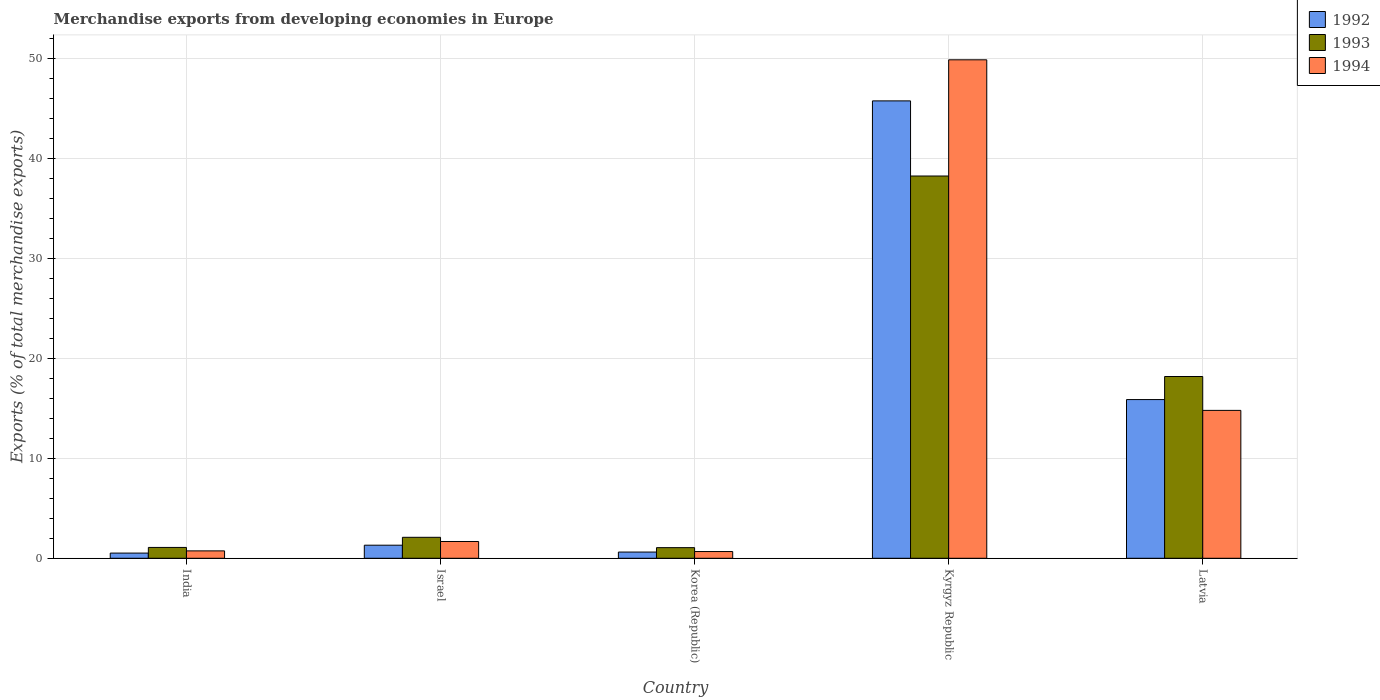How many bars are there on the 2nd tick from the right?
Give a very brief answer. 3. What is the label of the 4th group of bars from the left?
Give a very brief answer. Kyrgyz Republic. In how many cases, is the number of bars for a given country not equal to the number of legend labels?
Provide a succinct answer. 0. What is the percentage of total merchandise exports in 1993 in India?
Your answer should be very brief. 1.08. Across all countries, what is the maximum percentage of total merchandise exports in 1994?
Your answer should be compact. 49.84. Across all countries, what is the minimum percentage of total merchandise exports in 1993?
Your answer should be very brief. 1.06. In which country was the percentage of total merchandise exports in 1992 maximum?
Make the answer very short. Kyrgyz Republic. What is the total percentage of total merchandise exports in 1993 in the graph?
Your answer should be compact. 60.63. What is the difference between the percentage of total merchandise exports in 1993 in Israel and that in Korea (Republic)?
Your response must be concise. 1.03. What is the difference between the percentage of total merchandise exports in 1993 in Kyrgyz Republic and the percentage of total merchandise exports in 1994 in Latvia?
Your answer should be compact. 23.43. What is the average percentage of total merchandise exports in 1993 per country?
Provide a short and direct response. 12.13. What is the difference between the percentage of total merchandise exports of/in 1992 and percentage of total merchandise exports of/in 1993 in Korea (Republic)?
Ensure brevity in your answer.  -0.44. What is the ratio of the percentage of total merchandise exports in 1992 in Israel to that in Latvia?
Offer a very short reply. 0.08. Is the difference between the percentage of total merchandise exports in 1992 in Israel and Kyrgyz Republic greater than the difference between the percentage of total merchandise exports in 1993 in Israel and Kyrgyz Republic?
Keep it short and to the point. No. What is the difference between the highest and the second highest percentage of total merchandise exports in 1993?
Offer a terse response. 16.08. What is the difference between the highest and the lowest percentage of total merchandise exports in 1994?
Your answer should be compact. 49.16. In how many countries, is the percentage of total merchandise exports in 1993 greater than the average percentage of total merchandise exports in 1993 taken over all countries?
Your response must be concise. 2. Is the sum of the percentage of total merchandise exports in 1993 in India and Latvia greater than the maximum percentage of total merchandise exports in 1992 across all countries?
Your answer should be compact. No. What does the 3rd bar from the left in Kyrgyz Republic represents?
Provide a short and direct response. 1994. Is it the case that in every country, the sum of the percentage of total merchandise exports in 1992 and percentage of total merchandise exports in 1994 is greater than the percentage of total merchandise exports in 1993?
Make the answer very short. Yes. How many bars are there?
Offer a very short reply. 15. Are all the bars in the graph horizontal?
Your answer should be compact. No. How many countries are there in the graph?
Provide a succinct answer. 5. Does the graph contain any zero values?
Your answer should be compact. No. Where does the legend appear in the graph?
Provide a short and direct response. Top right. How many legend labels are there?
Provide a short and direct response. 3. How are the legend labels stacked?
Keep it short and to the point. Vertical. What is the title of the graph?
Offer a very short reply. Merchandise exports from developing economies in Europe. Does "1974" appear as one of the legend labels in the graph?
Make the answer very short. No. What is the label or title of the X-axis?
Keep it short and to the point. Country. What is the label or title of the Y-axis?
Give a very brief answer. Exports (% of total merchandise exports). What is the Exports (% of total merchandise exports) in 1992 in India?
Provide a succinct answer. 0.52. What is the Exports (% of total merchandise exports) in 1993 in India?
Provide a succinct answer. 1.08. What is the Exports (% of total merchandise exports) of 1994 in India?
Ensure brevity in your answer.  0.74. What is the Exports (% of total merchandise exports) in 1992 in Israel?
Keep it short and to the point. 1.31. What is the Exports (% of total merchandise exports) in 1993 in Israel?
Your answer should be very brief. 2.1. What is the Exports (% of total merchandise exports) of 1994 in Israel?
Your answer should be very brief. 1.68. What is the Exports (% of total merchandise exports) of 1992 in Korea (Republic)?
Offer a terse response. 0.62. What is the Exports (% of total merchandise exports) of 1993 in Korea (Republic)?
Your answer should be compact. 1.06. What is the Exports (% of total merchandise exports) of 1994 in Korea (Republic)?
Offer a very short reply. 0.67. What is the Exports (% of total merchandise exports) in 1992 in Kyrgyz Republic?
Offer a terse response. 45.73. What is the Exports (% of total merchandise exports) in 1993 in Kyrgyz Republic?
Ensure brevity in your answer.  38.22. What is the Exports (% of total merchandise exports) in 1994 in Kyrgyz Republic?
Make the answer very short. 49.84. What is the Exports (% of total merchandise exports) of 1992 in Latvia?
Ensure brevity in your answer.  15.87. What is the Exports (% of total merchandise exports) in 1993 in Latvia?
Provide a short and direct response. 18.17. What is the Exports (% of total merchandise exports) in 1994 in Latvia?
Your response must be concise. 14.79. Across all countries, what is the maximum Exports (% of total merchandise exports) of 1992?
Give a very brief answer. 45.73. Across all countries, what is the maximum Exports (% of total merchandise exports) in 1993?
Provide a succinct answer. 38.22. Across all countries, what is the maximum Exports (% of total merchandise exports) of 1994?
Your response must be concise. 49.84. Across all countries, what is the minimum Exports (% of total merchandise exports) of 1992?
Provide a succinct answer. 0.52. Across all countries, what is the minimum Exports (% of total merchandise exports) in 1993?
Offer a very short reply. 1.06. Across all countries, what is the minimum Exports (% of total merchandise exports) of 1994?
Your answer should be compact. 0.67. What is the total Exports (% of total merchandise exports) of 1992 in the graph?
Provide a short and direct response. 64.04. What is the total Exports (% of total merchandise exports) of 1993 in the graph?
Provide a short and direct response. 60.63. What is the total Exports (% of total merchandise exports) of 1994 in the graph?
Provide a short and direct response. 67.71. What is the difference between the Exports (% of total merchandise exports) of 1992 in India and that in Israel?
Offer a very short reply. -0.79. What is the difference between the Exports (% of total merchandise exports) in 1993 in India and that in Israel?
Your answer should be compact. -1.01. What is the difference between the Exports (% of total merchandise exports) in 1994 in India and that in Israel?
Provide a short and direct response. -0.94. What is the difference between the Exports (% of total merchandise exports) of 1992 in India and that in Korea (Republic)?
Provide a succinct answer. -0.1. What is the difference between the Exports (% of total merchandise exports) in 1993 in India and that in Korea (Republic)?
Provide a short and direct response. 0.02. What is the difference between the Exports (% of total merchandise exports) in 1994 in India and that in Korea (Republic)?
Your response must be concise. 0.07. What is the difference between the Exports (% of total merchandise exports) of 1992 in India and that in Kyrgyz Republic?
Your response must be concise. -45.21. What is the difference between the Exports (% of total merchandise exports) of 1993 in India and that in Kyrgyz Republic?
Ensure brevity in your answer.  -37.13. What is the difference between the Exports (% of total merchandise exports) of 1994 in India and that in Kyrgyz Republic?
Give a very brief answer. -49.1. What is the difference between the Exports (% of total merchandise exports) in 1992 in India and that in Latvia?
Your answer should be compact. -15.35. What is the difference between the Exports (% of total merchandise exports) in 1993 in India and that in Latvia?
Provide a short and direct response. -17.09. What is the difference between the Exports (% of total merchandise exports) in 1994 in India and that in Latvia?
Your answer should be very brief. -14.05. What is the difference between the Exports (% of total merchandise exports) in 1992 in Israel and that in Korea (Republic)?
Ensure brevity in your answer.  0.69. What is the difference between the Exports (% of total merchandise exports) in 1993 in Israel and that in Korea (Republic)?
Give a very brief answer. 1.03. What is the difference between the Exports (% of total merchandise exports) in 1992 in Israel and that in Kyrgyz Republic?
Ensure brevity in your answer.  -44.42. What is the difference between the Exports (% of total merchandise exports) of 1993 in Israel and that in Kyrgyz Republic?
Offer a very short reply. -36.12. What is the difference between the Exports (% of total merchandise exports) of 1994 in Israel and that in Kyrgyz Republic?
Your response must be concise. -48.16. What is the difference between the Exports (% of total merchandise exports) in 1992 in Israel and that in Latvia?
Offer a very short reply. -14.56. What is the difference between the Exports (% of total merchandise exports) of 1993 in Israel and that in Latvia?
Your answer should be compact. -16.08. What is the difference between the Exports (% of total merchandise exports) in 1994 in Israel and that in Latvia?
Offer a terse response. -13.11. What is the difference between the Exports (% of total merchandise exports) of 1992 in Korea (Republic) and that in Kyrgyz Republic?
Your answer should be very brief. -45.11. What is the difference between the Exports (% of total merchandise exports) of 1993 in Korea (Republic) and that in Kyrgyz Republic?
Keep it short and to the point. -37.16. What is the difference between the Exports (% of total merchandise exports) in 1994 in Korea (Republic) and that in Kyrgyz Republic?
Ensure brevity in your answer.  -49.16. What is the difference between the Exports (% of total merchandise exports) in 1992 in Korea (Republic) and that in Latvia?
Your response must be concise. -15.25. What is the difference between the Exports (% of total merchandise exports) of 1993 in Korea (Republic) and that in Latvia?
Provide a short and direct response. -17.11. What is the difference between the Exports (% of total merchandise exports) of 1994 in Korea (Republic) and that in Latvia?
Your answer should be compact. -14.11. What is the difference between the Exports (% of total merchandise exports) in 1992 in Kyrgyz Republic and that in Latvia?
Offer a terse response. 29.86. What is the difference between the Exports (% of total merchandise exports) of 1993 in Kyrgyz Republic and that in Latvia?
Your response must be concise. 20.04. What is the difference between the Exports (% of total merchandise exports) of 1994 in Kyrgyz Republic and that in Latvia?
Ensure brevity in your answer.  35.05. What is the difference between the Exports (% of total merchandise exports) of 1992 in India and the Exports (% of total merchandise exports) of 1993 in Israel?
Provide a short and direct response. -1.58. What is the difference between the Exports (% of total merchandise exports) of 1992 in India and the Exports (% of total merchandise exports) of 1994 in Israel?
Give a very brief answer. -1.16. What is the difference between the Exports (% of total merchandise exports) in 1993 in India and the Exports (% of total merchandise exports) in 1994 in Israel?
Your answer should be very brief. -0.59. What is the difference between the Exports (% of total merchandise exports) of 1992 in India and the Exports (% of total merchandise exports) of 1993 in Korea (Republic)?
Provide a succinct answer. -0.54. What is the difference between the Exports (% of total merchandise exports) of 1992 in India and the Exports (% of total merchandise exports) of 1994 in Korea (Republic)?
Your answer should be very brief. -0.15. What is the difference between the Exports (% of total merchandise exports) of 1993 in India and the Exports (% of total merchandise exports) of 1994 in Korea (Republic)?
Offer a terse response. 0.41. What is the difference between the Exports (% of total merchandise exports) of 1992 in India and the Exports (% of total merchandise exports) of 1993 in Kyrgyz Republic?
Make the answer very short. -37.7. What is the difference between the Exports (% of total merchandise exports) in 1992 in India and the Exports (% of total merchandise exports) in 1994 in Kyrgyz Republic?
Your response must be concise. -49.32. What is the difference between the Exports (% of total merchandise exports) of 1993 in India and the Exports (% of total merchandise exports) of 1994 in Kyrgyz Republic?
Your response must be concise. -48.75. What is the difference between the Exports (% of total merchandise exports) of 1992 in India and the Exports (% of total merchandise exports) of 1993 in Latvia?
Offer a very short reply. -17.65. What is the difference between the Exports (% of total merchandise exports) of 1992 in India and the Exports (% of total merchandise exports) of 1994 in Latvia?
Your answer should be compact. -14.27. What is the difference between the Exports (% of total merchandise exports) of 1993 in India and the Exports (% of total merchandise exports) of 1994 in Latvia?
Your response must be concise. -13.7. What is the difference between the Exports (% of total merchandise exports) in 1992 in Israel and the Exports (% of total merchandise exports) in 1993 in Korea (Republic)?
Give a very brief answer. 0.25. What is the difference between the Exports (% of total merchandise exports) in 1992 in Israel and the Exports (% of total merchandise exports) in 1994 in Korea (Republic)?
Offer a terse response. 0.63. What is the difference between the Exports (% of total merchandise exports) of 1993 in Israel and the Exports (% of total merchandise exports) of 1994 in Korea (Republic)?
Provide a short and direct response. 1.42. What is the difference between the Exports (% of total merchandise exports) of 1992 in Israel and the Exports (% of total merchandise exports) of 1993 in Kyrgyz Republic?
Your answer should be very brief. -36.91. What is the difference between the Exports (% of total merchandise exports) in 1992 in Israel and the Exports (% of total merchandise exports) in 1994 in Kyrgyz Republic?
Offer a very short reply. -48.53. What is the difference between the Exports (% of total merchandise exports) of 1993 in Israel and the Exports (% of total merchandise exports) of 1994 in Kyrgyz Republic?
Provide a short and direct response. -47.74. What is the difference between the Exports (% of total merchandise exports) of 1992 in Israel and the Exports (% of total merchandise exports) of 1993 in Latvia?
Offer a very short reply. -16.87. What is the difference between the Exports (% of total merchandise exports) in 1992 in Israel and the Exports (% of total merchandise exports) in 1994 in Latvia?
Your answer should be compact. -13.48. What is the difference between the Exports (% of total merchandise exports) in 1993 in Israel and the Exports (% of total merchandise exports) in 1994 in Latvia?
Ensure brevity in your answer.  -12.69. What is the difference between the Exports (% of total merchandise exports) of 1992 in Korea (Republic) and the Exports (% of total merchandise exports) of 1993 in Kyrgyz Republic?
Your answer should be very brief. -37.6. What is the difference between the Exports (% of total merchandise exports) in 1992 in Korea (Republic) and the Exports (% of total merchandise exports) in 1994 in Kyrgyz Republic?
Provide a short and direct response. -49.22. What is the difference between the Exports (% of total merchandise exports) of 1993 in Korea (Republic) and the Exports (% of total merchandise exports) of 1994 in Kyrgyz Republic?
Give a very brief answer. -48.77. What is the difference between the Exports (% of total merchandise exports) of 1992 in Korea (Republic) and the Exports (% of total merchandise exports) of 1993 in Latvia?
Provide a succinct answer. -17.55. What is the difference between the Exports (% of total merchandise exports) of 1992 in Korea (Republic) and the Exports (% of total merchandise exports) of 1994 in Latvia?
Give a very brief answer. -14.16. What is the difference between the Exports (% of total merchandise exports) of 1993 in Korea (Republic) and the Exports (% of total merchandise exports) of 1994 in Latvia?
Give a very brief answer. -13.72. What is the difference between the Exports (% of total merchandise exports) of 1992 in Kyrgyz Republic and the Exports (% of total merchandise exports) of 1993 in Latvia?
Your response must be concise. 27.56. What is the difference between the Exports (% of total merchandise exports) in 1992 in Kyrgyz Republic and the Exports (% of total merchandise exports) in 1994 in Latvia?
Your answer should be compact. 30.94. What is the difference between the Exports (% of total merchandise exports) of 1993 in Kyrgyz Republic and the Exports (% of total merchandise exports) of 1994 in Latvia?
Give a very brief answer. 23.43. What is the average Exports (% of total merchandise exports) of 1992 per country?
Ensure brevity in your answer.  12.81. What is the average Exports (% of total merchandise exports) of 1993 per country?
Your response must be concise. 12.13. What is the average Exports (% of total merchandise exports) of 1994 per country?
Offer a very short reply. 13.54. What is the difference between the Exports (% of total merchandise exports) of 1992 and Exports (% of total merchandise exports) of 1993 in India?
Offer a terse response. -0.56. What is the difference between the Exports (% of total merchandise exports) in 1992 and Exports (% of total merchandise exports) in 1994 in India?
Offer a terse response. -0.22. What is the difference between the Exports (% of total merchandise exports) in 1993 and Exports (% of total merchandise exports) in 1994 in India?
Ensure brevity in your answer.  0.34. What is the difference between the Exports (% of total merchandise exports) in 1992 and Exports (% of total merchandise exports) in 1993 in Israel?
Give a very brief answer. -0.79. What is the difference between the Exports (% of total merchandise exports) in 1992 and Exports (% of total merchandise exports) in 1994 in Israel?
Ensure brevity in your answer.  -0.37. What is the difference between the Exports (% of total merchandise exports) in 1993 and Exports (% of total merchandise exports) in 1994 in Israel?
Give a very brief answer. 0.42. What is the difference between the Exports (% of total merchandise exports) of 1992 and Exports (% of total merchandise exports) of 1993 in Korea (Republic)?
Give a very brief answer. -0.44. What is the difference between the Exports (% of total merchandise exports) in 1992 and Exports (% of total merchandise exports) in 1994 in Korea (Republic)?
Ensure brevity in your answer.  -0.05. What is the difference between the Exports (% of total merchandise exports) in 1993 and Exports (% of total merchandise exports) in 1994 in Korea (Republic)?
Make the answer very short. 0.39. What is the difference between the Exports (% of total merchandise exports) in 1992 and Exports (% of total merchandise exports) in 1993 in Kyrgyz Republic?
Keep it short and to the point. 7.51. What is the difference between the Exports (% of total merchandise exports) of 1992 and Exports (% of total merchandise exports) of 1994 in Kyrgyz Republic?
Your answer should be very brief. -4.11. What is the difference between the Exports (% of total merchandise exports) in 1993 and Exports (% of total merchandise exports) in 1994 in Kyrgyz Republic?
Your answer should be very brief. -11.62. What is the difference between the Exports (% of total merchandise exports) in 1992 and Exports (% of total merchandise exports) in 1993 in Latvia?
Your answer should be compact. -2.31. What is the difference between the Exports (% of total merchandise exports) of 1992 and Exports (% of total merchandise exports) of 1994 in Latvia?
Give a very brief answer. 1.08. What is the difference between the Exports (% of total merchandise exports) of 1993 and Exports (% of total merchandise exports) of 1994 in Latvia?
Your answer should be very brief. 3.39. What is the ratio of the Exports (% of total merchandise exports) of 1992 in India to that in Israel?
Provide a short and direct response. 0.4. What is the ratio of the Exports (% of total merchandise exports) of 1993 in India to that in Israel?
Make the answer very short. 0.52. What is the ratio of the Exports (% of total merchandise exports) of 1994 in India to that in Israel?
Provide a succinct answer. 0.44. What is the ratio of the Exports (% of total merchandise exports) in 1992 in India to that in Korea (Republic)?
Offer a terse response. 0.84. What is the ratio of the Exports (% of total merchandise exports) of 1993 in India to that in Korea (Republic)?
Ensure brevity in your answer.  1.02. What is the ratio of the Exports (% of total merchandise exports) of 1994 in India to that in Korea (Republic)?
Offer a terse response. 1.1. What is the ratio of the Exports (% of total merchandise exports) of 1992 in India to that in Kyrgyz Republic?
Keep it short and to the point. 0.01. What is the ratio of the Exports (% of total merchandise exports) in 1993 in India to that in Kyrgyz Republic?
Keep it short and to the point. 0.03. What is the ratio of the Exports (% of total merchandise exports) in 1994 in India to that in Kyrgyz Republic?
Your response must be concise. 0.01. What is the ratio of the Exports (% of total merchandise exports) of 1992 in India to that in Latvia?
Make the answer very short. 0.03. What is the ratio of the Exports (% of total merchandise exports) of 1993 in India to that in Latvia?
Offer a terse response. 0.06. What is the ratio of the Exports (% of total merchandise exports) in 1994 in India to that in Latvia?
Your answer should be compact. 0.05. What is the ratio of the Exports (% of total merchandise exports) in 1992 in Israel to that in Korea (Republic)?
Offer a terse response. 2.11. What is the ratio of the Exports (% of total merchandise exports) in 1993 in Israel to that in Korea (Republic)?
Offer a very short reply. 1.97. What is the ratio of the Exports (% of total merchandise exports) of 1994 in Israel to that in Korea (Republic)?
Make the answer very short. 2.49. What is the ratio of the Exports (% of total merchandise exports) of 1992 in Israel to that in Kyrgyz Republic?
Give a very brief answer. 0.03. What is the ratio of the Exports (% of total merchandise exports) of 1993 in Israel to that in Kyrgyz Republic?
Ensure brevity in your answer.  0.05. What is the ratio of the Exports (% of total merchandise exports) in 1994 in Israel to that in Kyrgyz Republic?
Provide a short and direct response. 0.03. What is the ratio of the Exports (% of total merchandise exports) of 1992 in Israel to that in Latvia?
Your answer should be very brief. 0.08. What is the ratio of the Exports (% of total merchandise exports) in 1993 in Israel to that in Latvia?
Make the answer very short. 0.12. What is the ratio of the Exports (% of total merchandise exports) in 1994 in Israel to that in Latvia?
Give a very brief answer. 0.11. What is the ratio of the Exports (% of total merchandise exports) of 1992 in Korea (Republic) to that in Kyrgyz Republic?
Give a very brief answer. 0.01. What is the ratio of the Exports (% of total merchandise exports) in 1993 in Korea (Republic) to that in Kyrgyz Republic?
Offer a terse response. 0.03. What is the ratio of the Exports (% of total merchandise exports) of 1994 in Korea (Republic) to that in Kyrgyz Republic?
Your answer should be compact. 0.01. What is the ratio of the Exports (% of total merchandise exports) of 1992 in Korea (Republic) to that in Latvia?
Your answer should be compact. 0.04. What is the ratio of the Exports (% of total merchandise exports) of 1993 in Korea (Republic) to that in Latvia?
Provide a succinct answer. 0.06. What is the ratio of the Exports (% of total merchandise exports) in 1994 in Korea (Republic) to that in Latvia?
Provide a succinct answer. 0.05. What is the ratio of the Exports (% of total merchandise exports) of 1992 in Kyrgyz Republic to that in Latvia?
Make the answer very short. 2.88. What is the ratio of the Exports (% of total merchandise exports) in 1993 in Kyrgyz Republic to that in Latvia?
Provide a succinct answer. 2.1. What is the ratio of the Exports (% of total merchandise exports) in 1994 in Kyrgyz Republic to that in Latvia?
Provide a succinct answer. 3.37. What is the difference between the highest and the second highest Exports (% of total merchandise exports) of 1992?
Offer a very short reply. 29.86. What is the difference between the highest and the second highest Exports (% of total merchandise exports) of 1993?
Your answer should be compact. 20.04. What is the difference between the highest and the second highest Exports (% of total merchandise exports) in 1994?
Offer a terse response. 35.05. What is the difference between the highest and the lowest Exports (% of total merchandise exports) in 1992?
Offer a very short reply. 45.21. What is the difference between the highest and the lowest Exports (% of total merchandise exports) in 1993?
Your answer should be very brief. 37.16. What is the difference between the highest and the lowest Exports (% of total merchandise exports) in 1994?
Your answer should be compact. 49.16. 